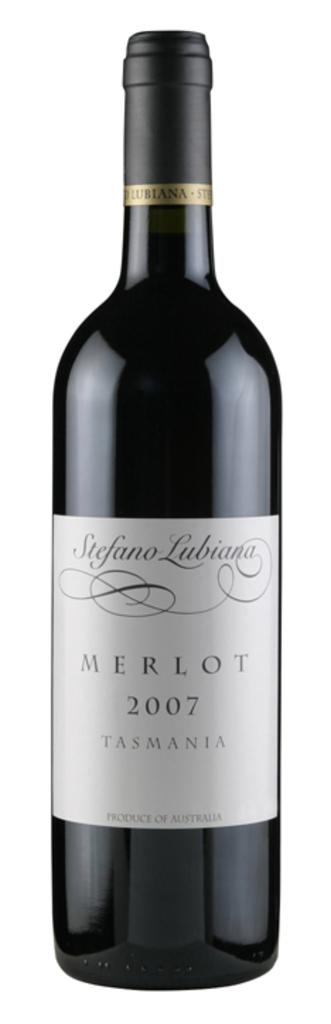Provide a one-sentence caption for the provided image. Stefano Lubiana merlot tasmania wine that is unopened. 